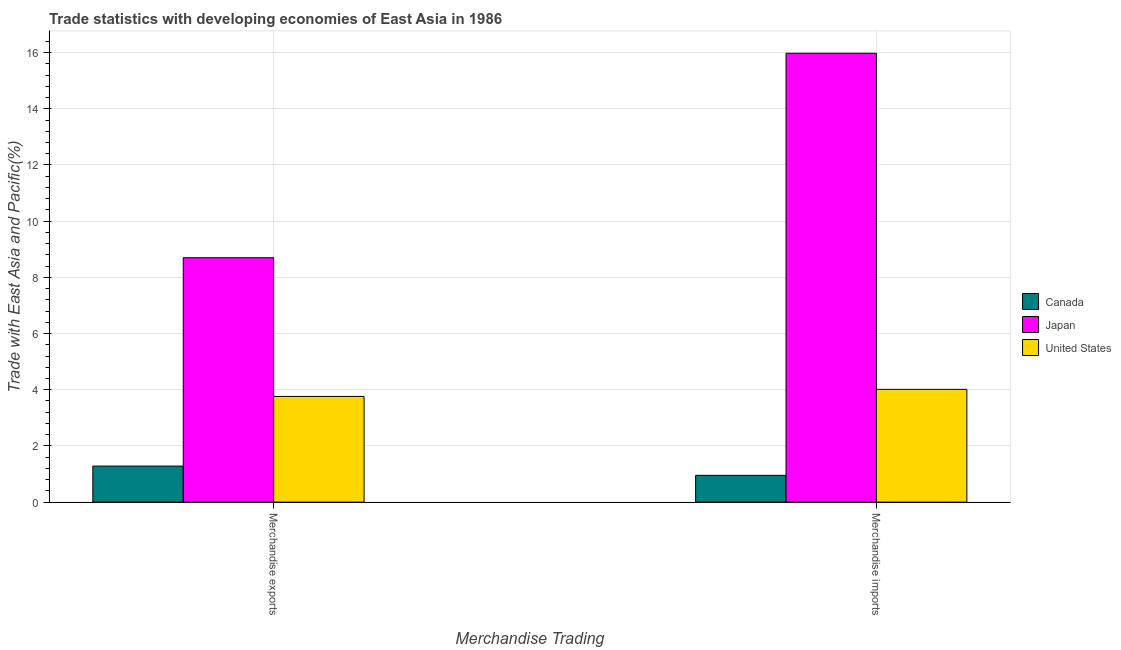How many different coloured bars are there?
Make the answer very short. 3. How many bars are there on the 2nd tick from the left?
Your answer should be very brief. 3. How many bars are there on the 1st tick from the right?
Make the answer very short. 3. What is the label of the 1st group of bars from the left?
Give a very brief answer. Merchandise exports. What is the merchandise exports in United States?
Ensure brevity in your answer.  3.76. Across all countries, what is the maximum merchandise exports?
Keep it short and to the point. 8.7. Across all countries, what is the minimum merchandise imports?
Make the answer very short. 0.95. What is the total merchandise imports in the graph?
Offer a terse response. 20.94. What is the difference between the merchandise exports in Canada and that in United States?
Provide a short and direct response. -2.48. What is the difference between the merchandise imports in United States and the merchandise exports in Canada?
Offer a terse response. 2.73. What is the average merchandise imports per country?
Your answer should be very brief. 6.98. What is the difference between the merchandise exports and merchandise imports in Japan?
Your answer should be compact. -7.28. What is the ratio of the merchandise exports in United States to that in Japan?
Your answer should be very brief. 0.43. Is the merchandise imports in Japan less than that in United States?
Offer a very short reply. No. In how many countries, is the merchandise imports greater than the average merchandise imports taken over all countries?
Ensure brevity in your answer.  1. What does the 1st bar from the right in Merchandise exports represents?
Keep it short and to the point. United States. How many bars are there?
Make the answer very short. 6. What is the difference between two consecutive major ticks on the Y-axis?
Your answer should be very brief. 2. Does the graph contain grids?
Offer a terse response. Yes. How many legend labels are there?
Your answer should be compact. 3. What is the title of the graph?
Keep it short and to the point. Trade statistics with developing economies of East Asia in 1986. What is the label or title of the X-axis?
Offer a terse response. Merchandise Trading. What is the label or title of the Y-axis?
Give a very brief answer. Trade with East Asia and Pacific(%). What is the Trade with East Asia and Pacific(%) of Canada in Merchandise exports?
Your answer should be compact. 1.28. What is the Trade with East Asia and Pacific(%) in Japan in Merchandise exports?
Provide a succinct answer. 8.7. What is the Trade with East Asia and Pacific(%) in United States in Merchandise exports?
Your response must be concise. 3.76. What is the Trade with East Asia and Pacific(%) in Canada in Merchandise imports?
Your response must be concise. 0.95. What is the Trade with East Asia and Pacific(%) of Japan in Merchandise imports?
Provide a succinct answer. 15.98. What is the Trade with East Asia and Pacific(%) of United States in Merchandise imports?
Provide a succinct answer. 4.01. Across all Merchandise Trading, what is the maximum Trade with East Asia and Pacific(%) of Canada?
Make the answer very short. 1.28. Across all Merchandise Trading, what is the maximum Trade with East Asia and Pacific(%) of Japan?
Ensure brevity in your answer.  15.98. Across all Merchandise Trading, what is the maximum Trade with East Asia and Pacific(%) in United States?
Your answer should be very brief. 4.01. Across all Merchandise Trading, what is the minimum Trade with East Asia and Pacific(%) of Canada?
Offer a very short reply. 0.95. Across all Merchandise Trading, what is the minimum Trade with East Asia and Pacific(%) of Japan?
Ensure brevity in your answer.  8.7. Across all Merchandise Trading, what is the minimum Trade with East Asia and Pacific(%) of United States?
Keep it short and to the point. 3.76. What is the total Trade with East Asia and Pacific(%) in Canada in the graph?
Your answer should be compact. 2.24. What is the total Trade with East Asia and Pacific(%) in Japan in the graph?
Offer a terse response. 24.68. What is the total Trade with East Asia and Pacific(%) in United States in the graph?
Ensure brevity in your answer.  7.78. What is the difference between the Trade with East Asia and Pacific(%) in Canada in Merchandise exports and that in Merchandise imports?
Give a very brief answer. 0.33. What is the difference between the Trade with East Asia and Pacific(%) in Japan in Merchandise exports and that in Merchandise imports?
Offer a very short reply. -7.28. What is the difference between the Trade with East Asia and Pacific(%) in United States in Merchandise exports and that in Merchandise imports?
Your answer should be very brief. -0.25. What is the difference between the Trade with East Asia and Pacific(%) in Canada in Merchandise exports and the Trade with East Asia and Pacific(%) in Japan in Merchandise imports?
Give a very brief answer. -14.69. What is the difference between the Trade with East Asia and Pacific(%) of Canada in Merchandise exports and the Trade with East Asia and Pacific(%) of United States in Merchandise imports?
Ensure brevity in your answer.  -2.73. What is the difference between the Trade with East Asia and Pacific(%) in Japan in Merchandise exports and the Trade with East Asia and Pacific(%) in United States in Merchandise imports?
Your answer should be compact. 4.69. What is the average Trade with East Asia and Pacific(%) of Canada per Merchandise Trading?
Your answer should be compact. 1.12. What is the average Trade with East Asia and Pacific(%) in Japan per Merchandise Trading?
Keep it short and to the point. 12.34. What is the average Trade with East Asia and Pacific(%) in United States per Merchandise Trading?
Provide a short and direct response. 3.89. What is the difference between the Trade with East Asia and Pacific(%) in Canada and Trade with East Asia and Pacific(%) in Japan in Merchandise exports?
Offer a terse response. -7.42. What is the difference between the Trade with East Asia and Pacific(%) of Canada and Trade with East Asia and Pacific(%) of United States in Merchandise exports?
Offer a very short reply. -2.48. What is the difference between the Trade with East Asia and Pacific(%) in Japan and Trade with East Asia and Pacific(%) in United States in Merchandise exports?
Your answer should be compact. 4.94. What is the difference between the Trade with East Asia and Pacific(%) in Canada and Trade with East Asia and Pacific(%) in Japan in Merchandise imports?
Give a very brief answer. -15.02. What is the difference between the Trade with East Asia and Pacific(%) in Canada and Trade with East Asia and Pacific(%) in United States in Merchandise imports?
Offer a very short reply. -3.06. What is the difference between the Trade with East Asia and Pacific(%) of Japan and Trade with East Asia and Pacific(%) of United States in Merchandise imports?
Your answer should be compact. 11.96. What is the ratio of the Trade with East Asia and Pacific(%) in Canada in Merchandise exports to that in Merchandise imports?
Give a very brief answer. 1.34. What is the ratio of the Trade with East Asia and Pacific(%) in Japan in Merchandise exports to that in Merchandise imports?
Offer a very short reply. 0.54. What is the ratio of the Trade with East Asia and Pacific(%) of United States in Merchandise exports to that in Merchandise imports?
Provide a short and direct response. 0.94. What is the difference between the highest and the second highest Trade with East Asia and Pacific(%) in Canada?
Ensure brevity in your answer.  0.33. What is the difference between the highest and the second highest Trade with East Asia and Pacific(%) of Japan?
Ensure brevity in your answer.  7.28. What is the difference between the highest and the second highest Trade with East Asia and Pacific(%) in United States?
Ensure brevity in your answer.  0.25. What is the difference between the highest and the lowest Trade with East Asia and Pacific(%) of Canada?
Offer a terse response. 0.33. What is the difference between the highest and the lowest Trade with East Asia and Pacific(%) of Japan?
Provide a short and direct response. 7.28. What is the difference between the highest and the lowest Trade with East Asia and Pacific(%) of United States?
Provide a succinct answer. 0.25. 